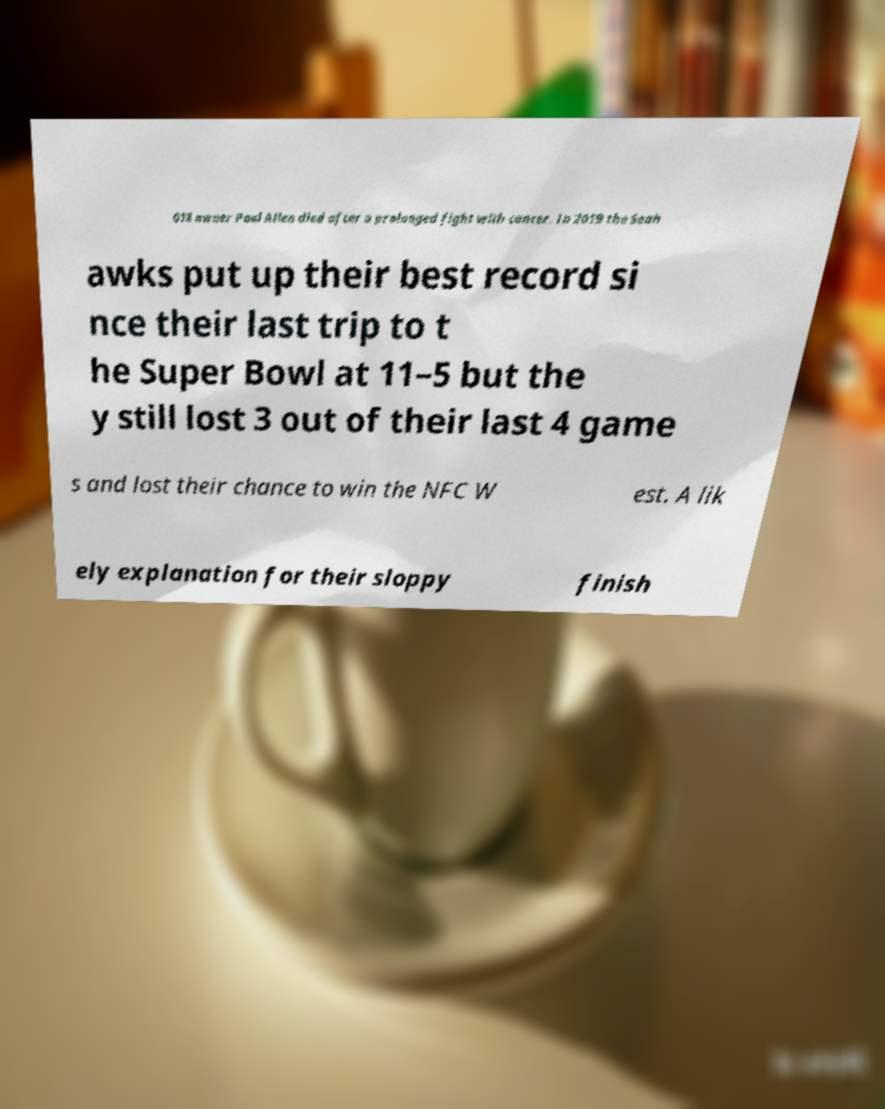What messages or text are displayed in this image? I need them in a readable, typed format. 018 owner Paul Allen died after a prolonged fight with cancer. In 2019 the Seah awks put up their best record si nce their last trip to t he Super Bowl at 11–5 but the y still lost 3 out of their last 4 game s and lost their chance to win the NFC W est. A lik ely explanation for their sloppy finish 